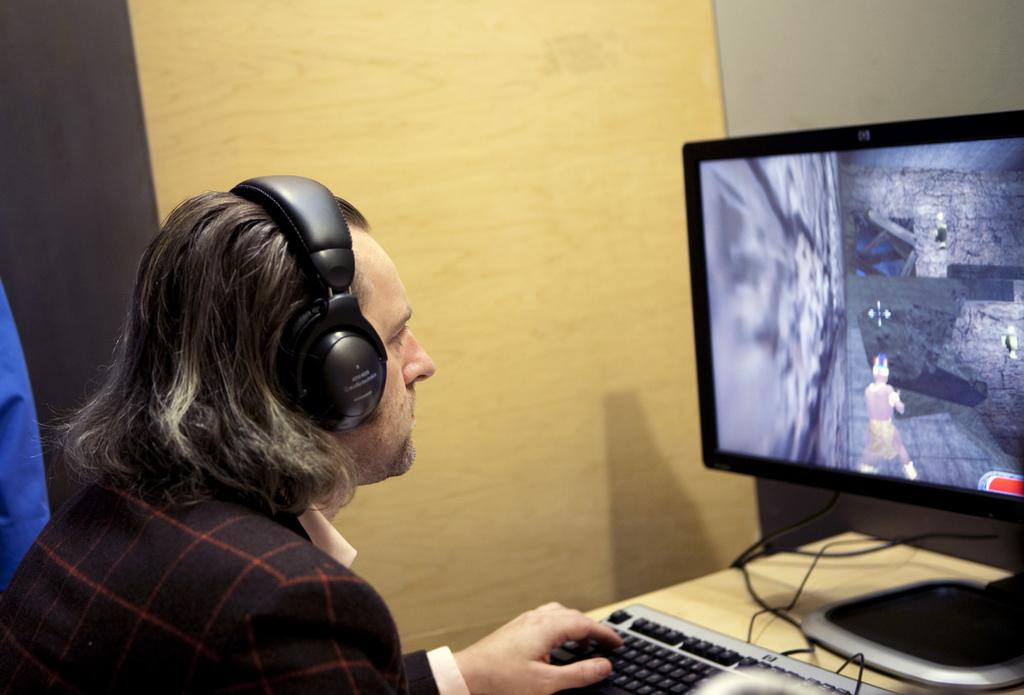Who is in the image? There is a person in the image. What is the person wearing? The person is wearing headphones. What can be seen on the table in the image? There is a keyboard and a computer on the table. What is visible in the background of the image? There is a wall in the background of the image. How many rabbits are hopping around the person in the image? There are no rabbits present in the image. What rule is the person following while wearing the headphones in the image? There is no rule mentioned or implied in the image; the person is simply wearing headphones. 